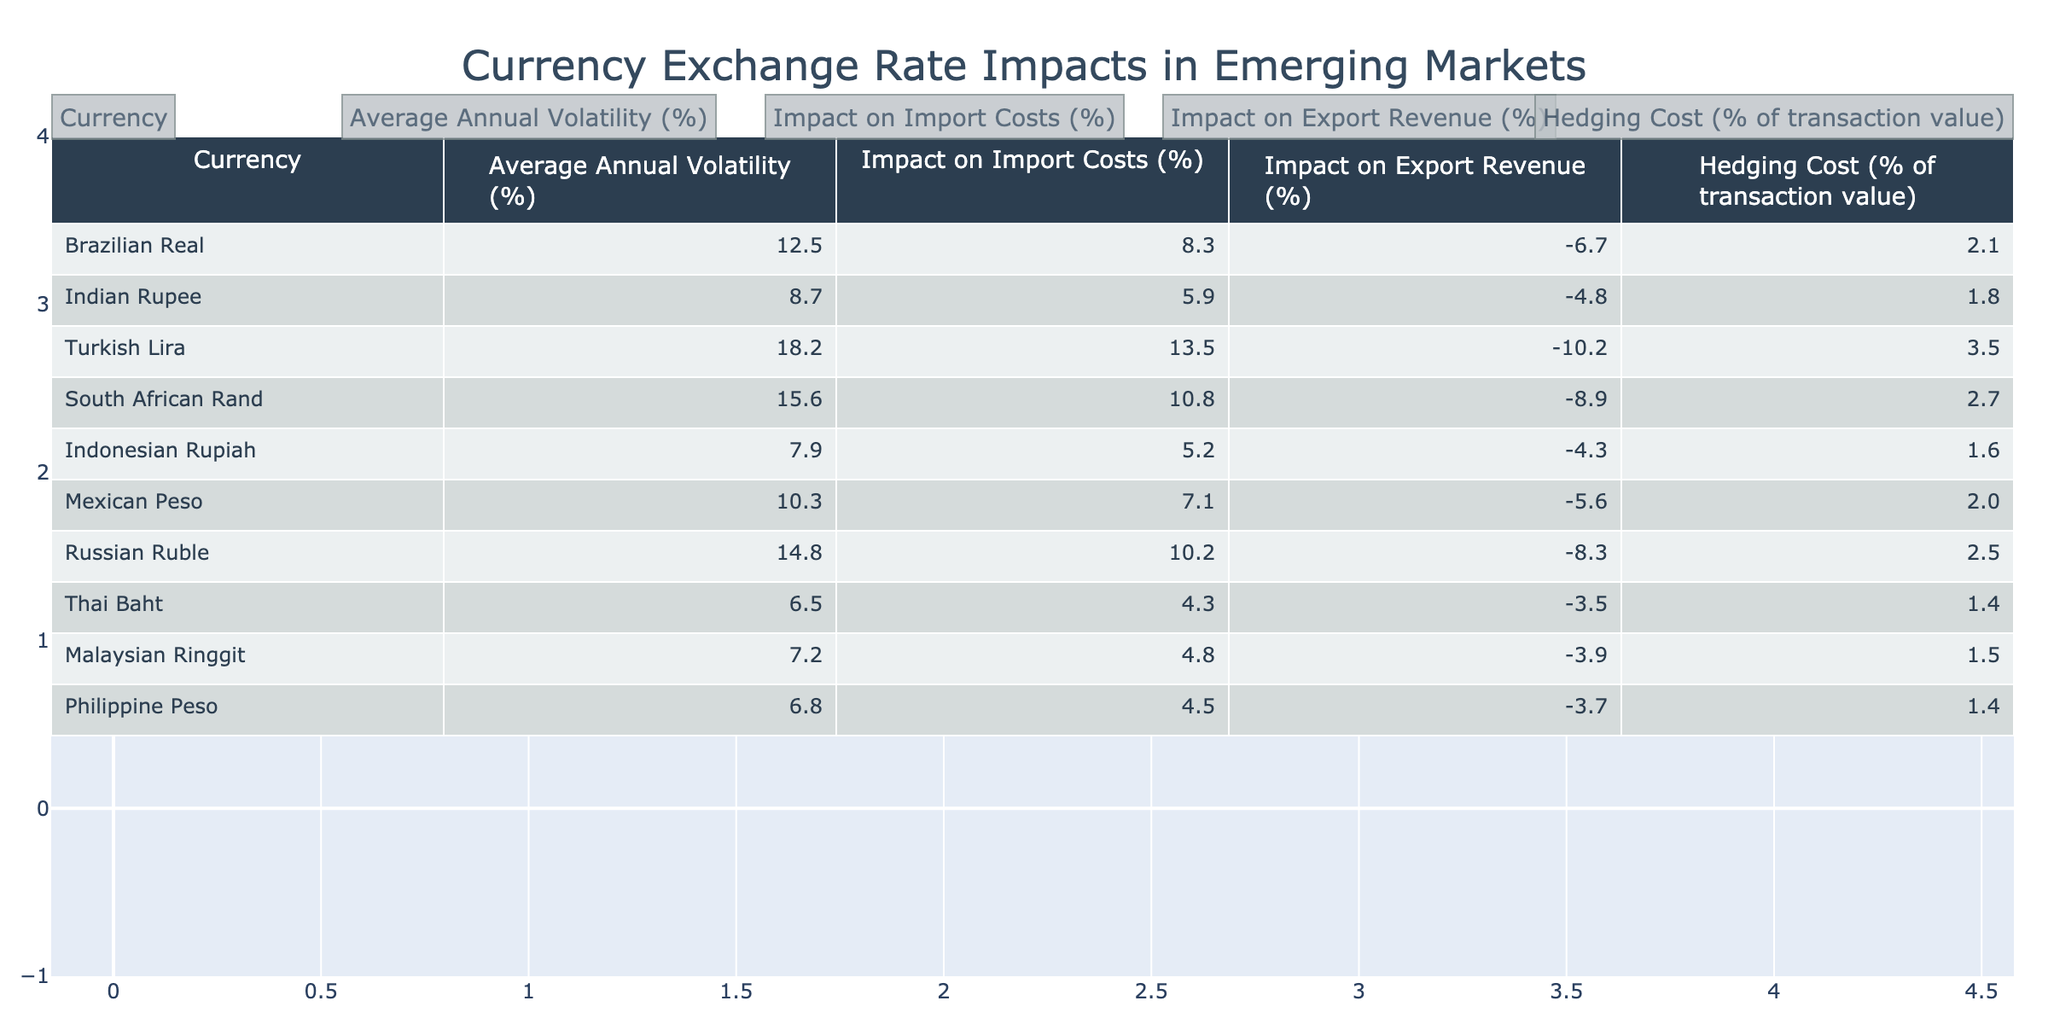What is the average annual volatility of the Turkish Lira? The table shows that the average annual volatility for the Turkish Lira is listed under the corresponding column. According to the data, it is 18.2%.
Answer: 18.2% Which currency has the highest impact on import costs? Looking at the "Impact on Import Costs" column, the highest value is 13.5% for the Turkish Lira.
Answer: Turkish Lira Which currency has the lowest hedging cost? The "Hedging Cost (% of transaction value)" column indicates the lowest value as 1.4% for both the Thai Baht and Philippine Peso.
Answer: Thai Baht and Philippine Peso Is the impact on export revenue for the Indian Rupee negative? The data under "Impact on Export Revenue" for the Indian Rupee shows a value of -4.8%, indicating it is negative.
Answer: Yes Which currency experiences the highest average annual volatility compared to the average of all currencies listed? First, we calculate the average volatility by adding all the volatility percentages (12.5 + 8.7 + 18.2 + 15.6 + 7.9 + 10.3 + 14.8 + 6.5 + 7.2 + 6.8) and dividing by 10, which equals 11.65%. Compared to this average, the Turkish Lira has the highest volatility at 18.2%.
Answer: Turkish Lira What is the impact on import costs and export revenue for the South African Rand? The "Impact on Import Costs" for the South African Rand is +10.8% and the "Impact on Export Revenue" is -8.9%.
Answer: +10.8% import cost, -8.9% export revenue If a business is importing goods valued at $10,000 using the Brazilian Real, what would be the additional cost due to the exchange rate fluctuation? To find the additional cost, we apply the percentage increase in import costs (+8.3%) to the value of $10,000. This calculation gives us an extra cost of $10,000 * 0.083 = $830.
Answer: $830 What is the difference between the impact on export revenue for the Mexican Peso and the Indonesian Rupiah? The impact for the Mexican Peso is -5.6% and for the Indonesian Rupiah is -4.3%. The difference is calculated as -5.6% - (-4.3%) = -1.3%.
Answer: -1.3% Which currency would involve the highest hedging cost for import transactions? The "Hedging Cost (% of transaction value)" column indicates the highest value is 3.5% for the Turkish Lira.
Answer: Turkish Lira Calculating the average impact on export revenue for all listed currencies, what is the result? First, we add the export revenue impacts: (-6.7 - 4.8 - 10.2 - 8.9 - 4.3 - 5.6 - 8.3 - 3.5 - 3.9 - 3.7) which equals -56.9%. We divide this by 10 to get an average of -5.69%.
Answer: -5.69% 